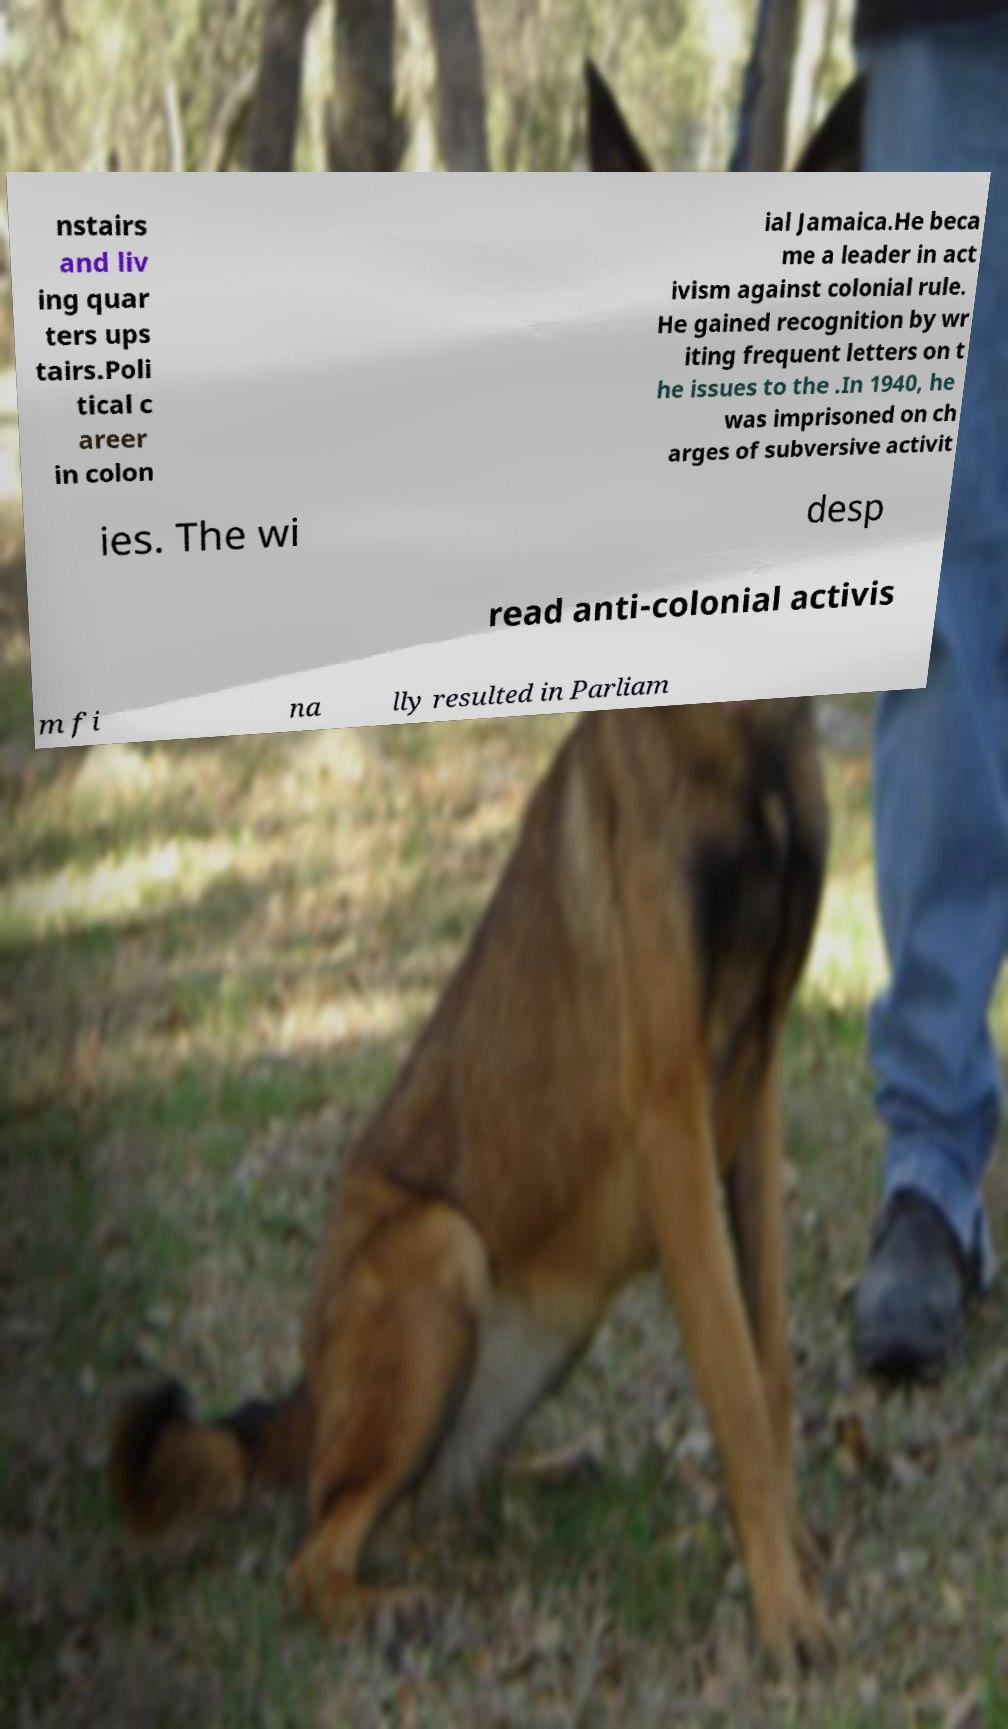Could you extract and type out the text from this image? nstairs and liv ing quar ters ups tairs.Poli tical c areer in colon ial Jamaica.He beca me a leader in act ivism against colonial rule. He gained recognition by wr iting frequent letters on t he issues to the .In 1940, he was imprisoned on ch arges of subversive activit ies. The wi desp read anti-colonial activis m fi na lly resulted in Parliam 